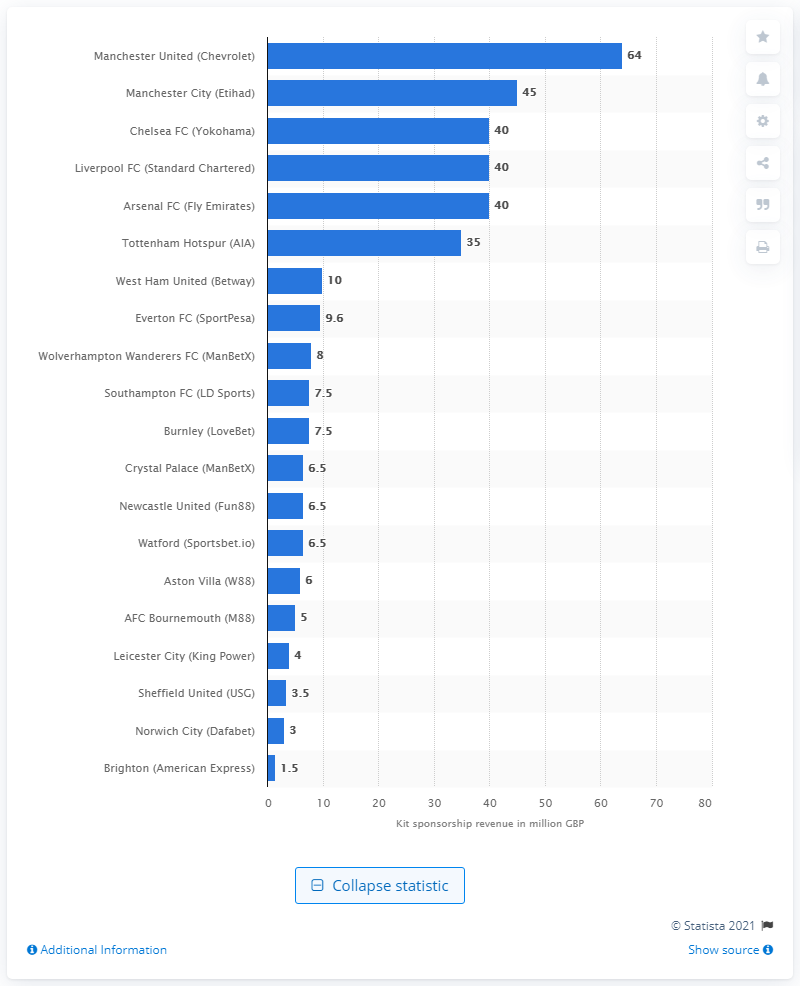Highlight a few significant elements in this photo. Manchester United earned $64 million in kit sponsorships during the 2019/2020 season. 